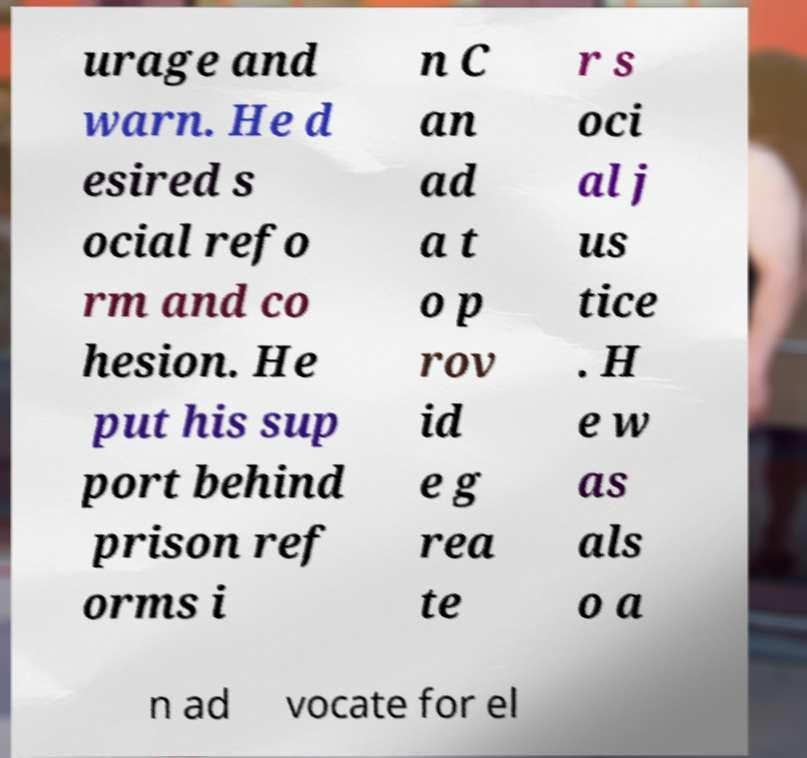Could you extract and type out the text from this image? urage and warn. He d esired s ocial refo rm and co hesion. He put his sup port behind prison ref orms i n C an ad a t o p rov id e g rea te r s oci al j us tice . H e w as als o a n ad vocate for el 